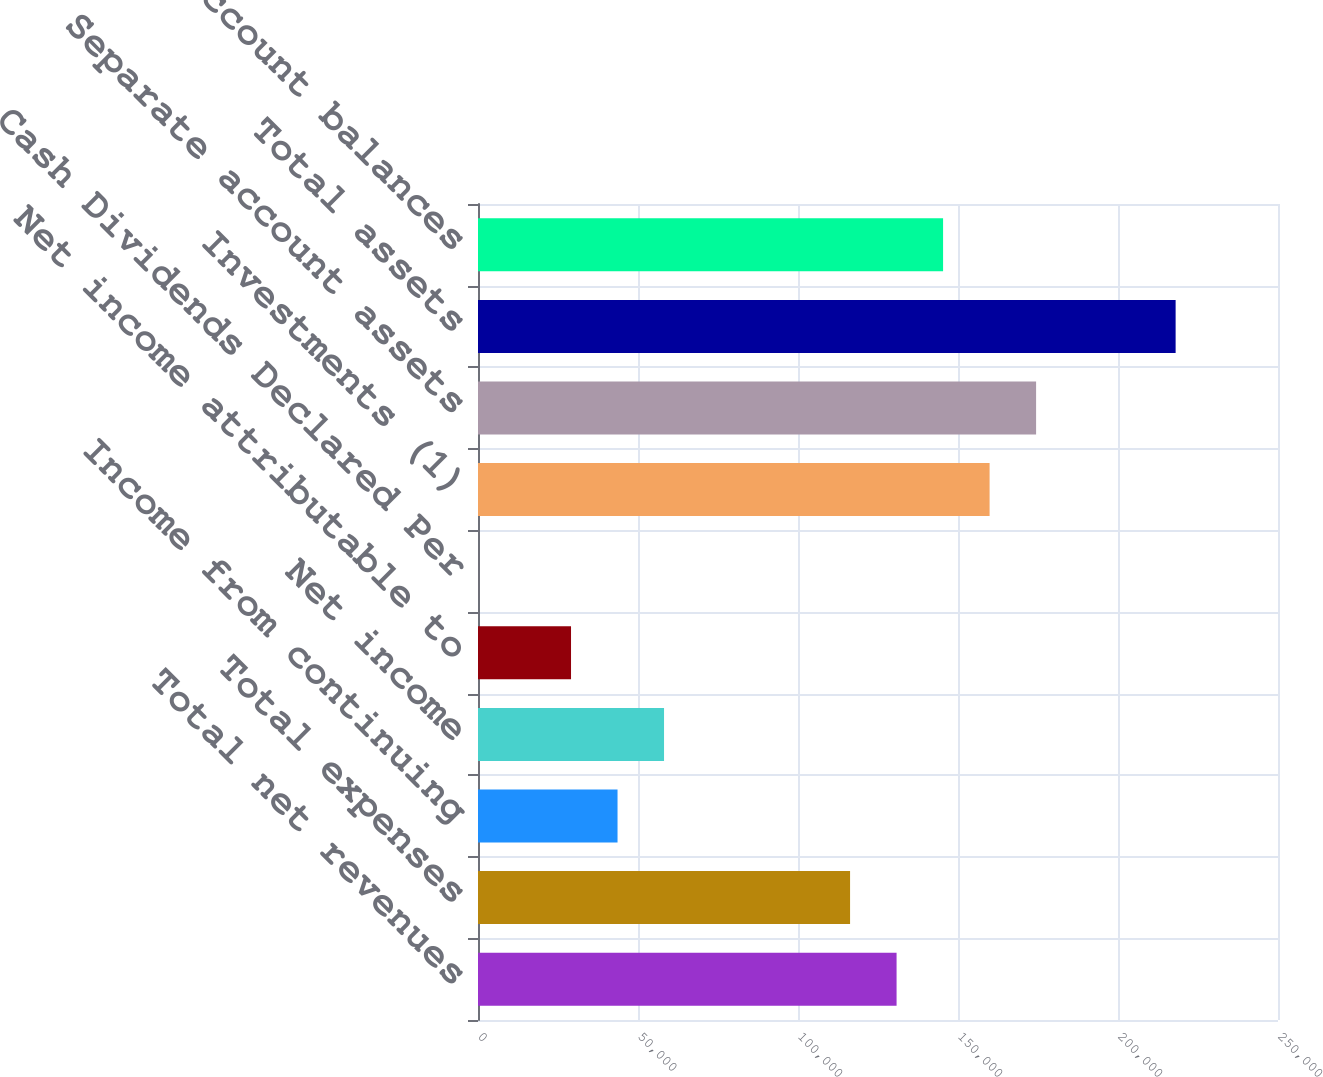Convert chart. <chart><loc_0><loc_0><loc_500><loc_500><bar_chart><fcel>Total net revenues<fcel>Total expenses<fcel>Income from continuing<fcel>Net income<fcel>Net income attributable to<fcel>Cash Dividends Declared Per<fcel>Investments (1)<fcel>Separate account assets<fcel>Total assets<fcel>Policyholder account balances<nl><fcel>130805<fcel>116272<fcel>43603.5<fcel>58137.2<fcel>29069.9<fcel>2.59<fcel>159873<fcel>174406<fcel>218007<fcel>145339<nl></chart> 